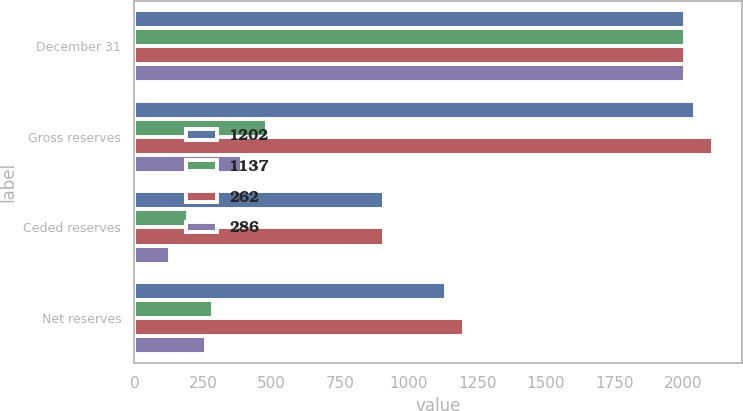Convert chart. <chart><loc_0><loc_0><loc_500><loc_500><stacked_bar_chart><ecel><fcel>December 31<fcel>Gross reserves<fcel>Ceded reserves<fcel>Net reserves<nl><fcel>1202<fcel>2009<fcel>2046<fcel>909<fcel>1137<nl><fcel>1137<fcel>2009<fcel>482<fcel>196<fcel>286<nl><fcel>262<fcel>2008<fcel>2112<fcel>910<fcel>1202<nl><fcel>286<fcel>2008<fcel>392<fcel>130<fcel>262<nl></chart> 